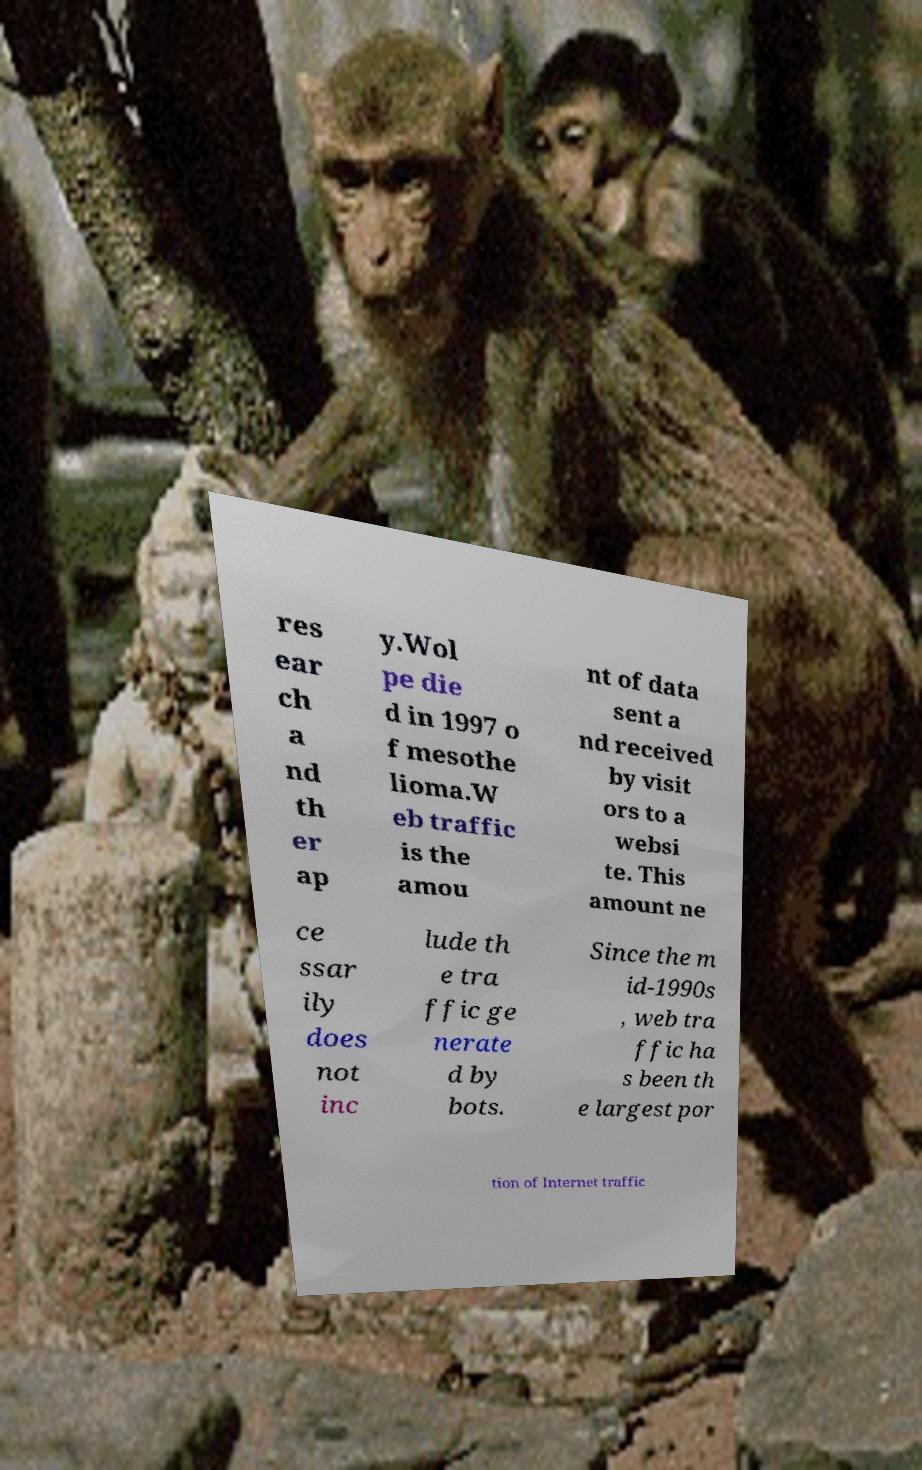Can you read and provide the text displayed in the image?This photo seems to have some interesting text. Can you extract and type it out for me? res ear ch a nd th er ap y.Wol pe die d in 1997 o f mesothe lioma.W eb traffic is the amou nt of data sent a nd received by visit ors to a websi te. This amount ne ce ssar ily does not inc lude th e tra ffic ge nerate d by bots. Since the m id-1990s , web tra ffic ha s been th e largest por tion of Internet traffic 